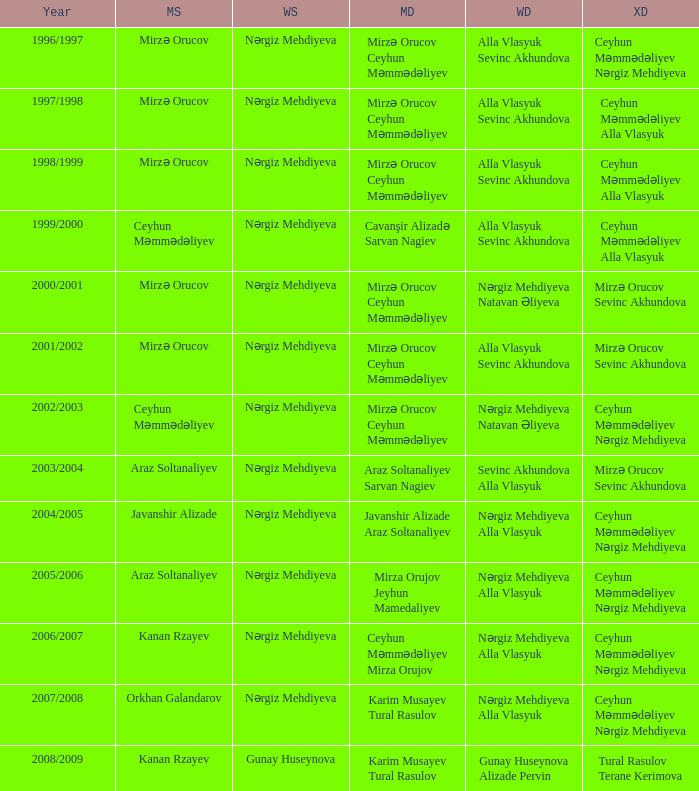What are all values for Womens Doubles in the year 2000/2001? Nərgiz Mehdiyeva Natavan Əliyeva. 